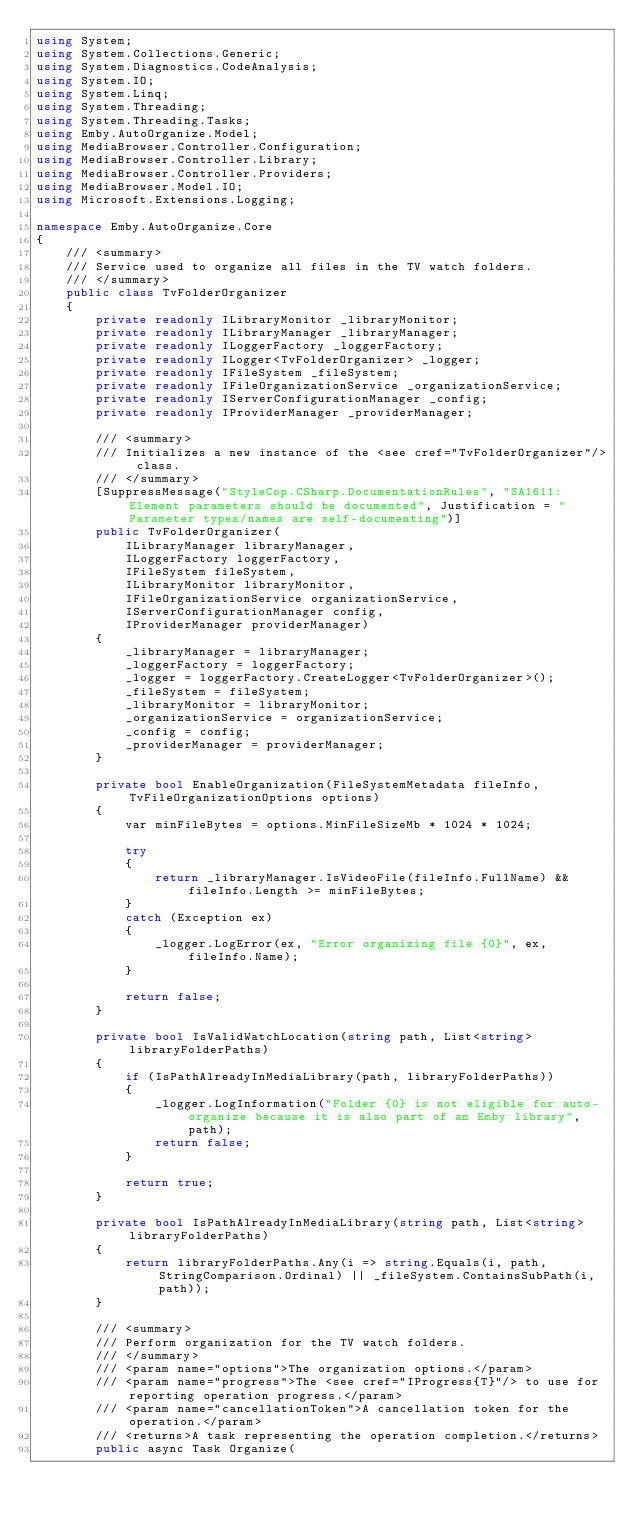Convert code to text. <code><loc_0><loc_0><loc_500><loc_500><_C#_>using System;
using System.Collections.Generic;
using System.Diagnostics.CodeAnalysis;
using System.IO;
using System.Linq;
using System.Threading;
using System.Threading.Tasks;
using Emby.AutoOrganize.Model;
using MediaBrowser.Controller.Configuration;
using MediaBrowser.Controller.Library;
using MediaBrowser.Controller.Providers;
using MediaBrowser.Model.IO;
using Microsoft.Extensions.Logging;

namespace Emby.AutoOrganize.Core
{
    /// <summary>
    /// Service used to organize all files in the TV watch folders.
    /// </summary>
    public class TvFolderOrganizer
    {
        private readonly ILibraryMonitor _libraryMonitor;
        private readonly ILibraryManager _libraryManager;
        private readonly ILoggerFactory _loggerFactory;
        private readonly ILogger<TvFolderOrganizer> _logger;
        private readonly IFileSystem _fileSystem;
        private readonly IFileOrganizationService _organizationService;
        private readonly IServerConfigurationManager _config;
        private readonly IProviderManager _providerManager;

        /// <summary>
        /// Initializes a new instance of the <see cref="TvFolderOrganizer"/> class.
        /// </summary>
        [SuppressMessage("StyleCop.CSharp.DocumentationRules", "SA1611:Element parameters should be documented", Justification = "Parameter types/names are self-documenting")]
        public TvFolderOrganizer(
            ILibraryManager libraryManager,
            ILoggerFactory loggerFactory,
            IFileSystem fileSystem,
            ILibraryMonitor libraryMonitor,
            IFileOrganizationService organizationService,
            IServerConfigurationManager config,
            IProviderManager providerManager)
        {
            _libraryManager = libraryManager;
            _loggerFactory = loggerFactory;
            _logger = loggerFactory.CreateLogger<TvFolderOrganizer>();
            _fileSystem = fileSystem;
            _libraryMonitor = libraryMonitor;
            _organizationService = organizationService;
            _config = config;
            _providerManager = providerManager;
        }

        private bool EnableOrganization(FileSystemMetadata fileInfo, TvFileOrganizationOptions options)
        {
            var minFileBytes = options.MinFileSizeMb * 1024 * 1024;

            try
            {
                return _libraryManager.IsVideoFile(fileInfo.FullName) && fileInfo.Length >= minFileBytes;
            }
            catch (Exception ex)
            {
                _logger.LogError(ex, "Error organizing file {0}", ex, fileInfo.Name);
            }

            return false;
        }

        private bool IsValidWatchLocation(string path, List<string> libraryFolderPaths)
        {
            if (IsPathAlreadyInMediaLibrary(path, libraryFolderPaths))
            {
                _logger.LogInformation("Folder {0} is not eligible for auto-organize because it is also part of an Emby library", path);
                return false;
            }

            return true;
        }

        private bool IsPathAlreadyInMediaLibrary(string path, List<string> libraryFolderPaths)
        {
            return libraryFolderPaths.Any(i => string.Equals(i, path, StringComparison.Ordinal) || _fileSystem.ContainsSubPath(i, path));
        }

        /// <summary>
        /// Perform organization for the TV watch folders.
        /// </summary>
        /// <param name="options">The organization options.</param>
        /// <param name="progress">The <see cref="IProgress{T}"/> to use for reporting operation progress.</param>
        /// <param name="cancellationToken">A cancellation token for the operation.</param>
        /// <returns>A task representing the operation completion.</returns>
        public async Task Organize(</code> 